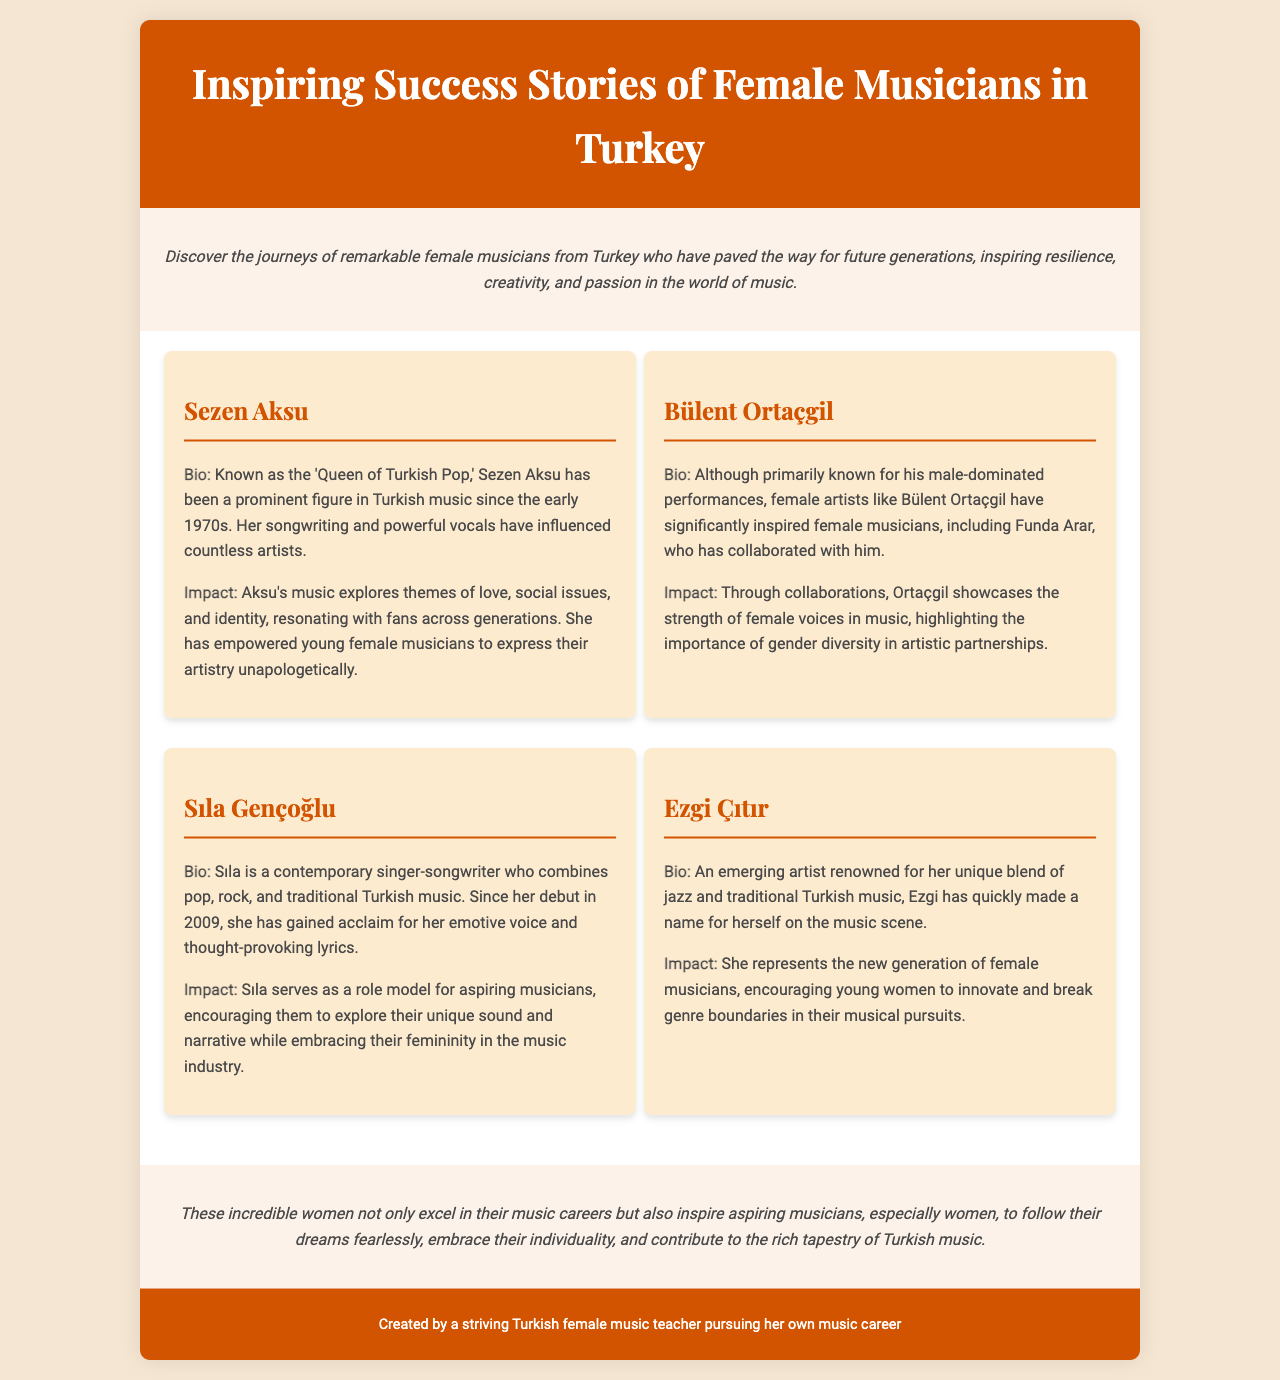What is the title of the brochure? The title of the brochure is presented at the top of the document.
Answer: Inspiring Success Stories of Female Musicians in Turkey Who is referred to as the 'Queen of Turkish Pop'? This information is detailed in the success stories section of the document.
Answer: Sezen Aksu In what year did Sıla begin her music career? The document mentions her debut year in the biography section.
Answer: 2009 How does Ezgi Çıtır blend music genres? The document explains her unique musical style in the impact section.
Answer: Jazz and traditional Turkish music Which artist has influenced Funda Arar? The influence on Funda Arar is mentioned in the bio of Bülent Ortaçgil.
Answer: Bülent Ortaçgil What is the primary theme of Sezen Aksu's music? The impact portion of her story discusses the themes she explores.
Answer: Love, social issues, and identity How do these female musicians inspire others? The conclusion of the brochure summarizes their influence.
Answer: Follow their dreams fearlessly What type of document is this? The nature of the content and format indicates its purpose.
Answer: Brochure 